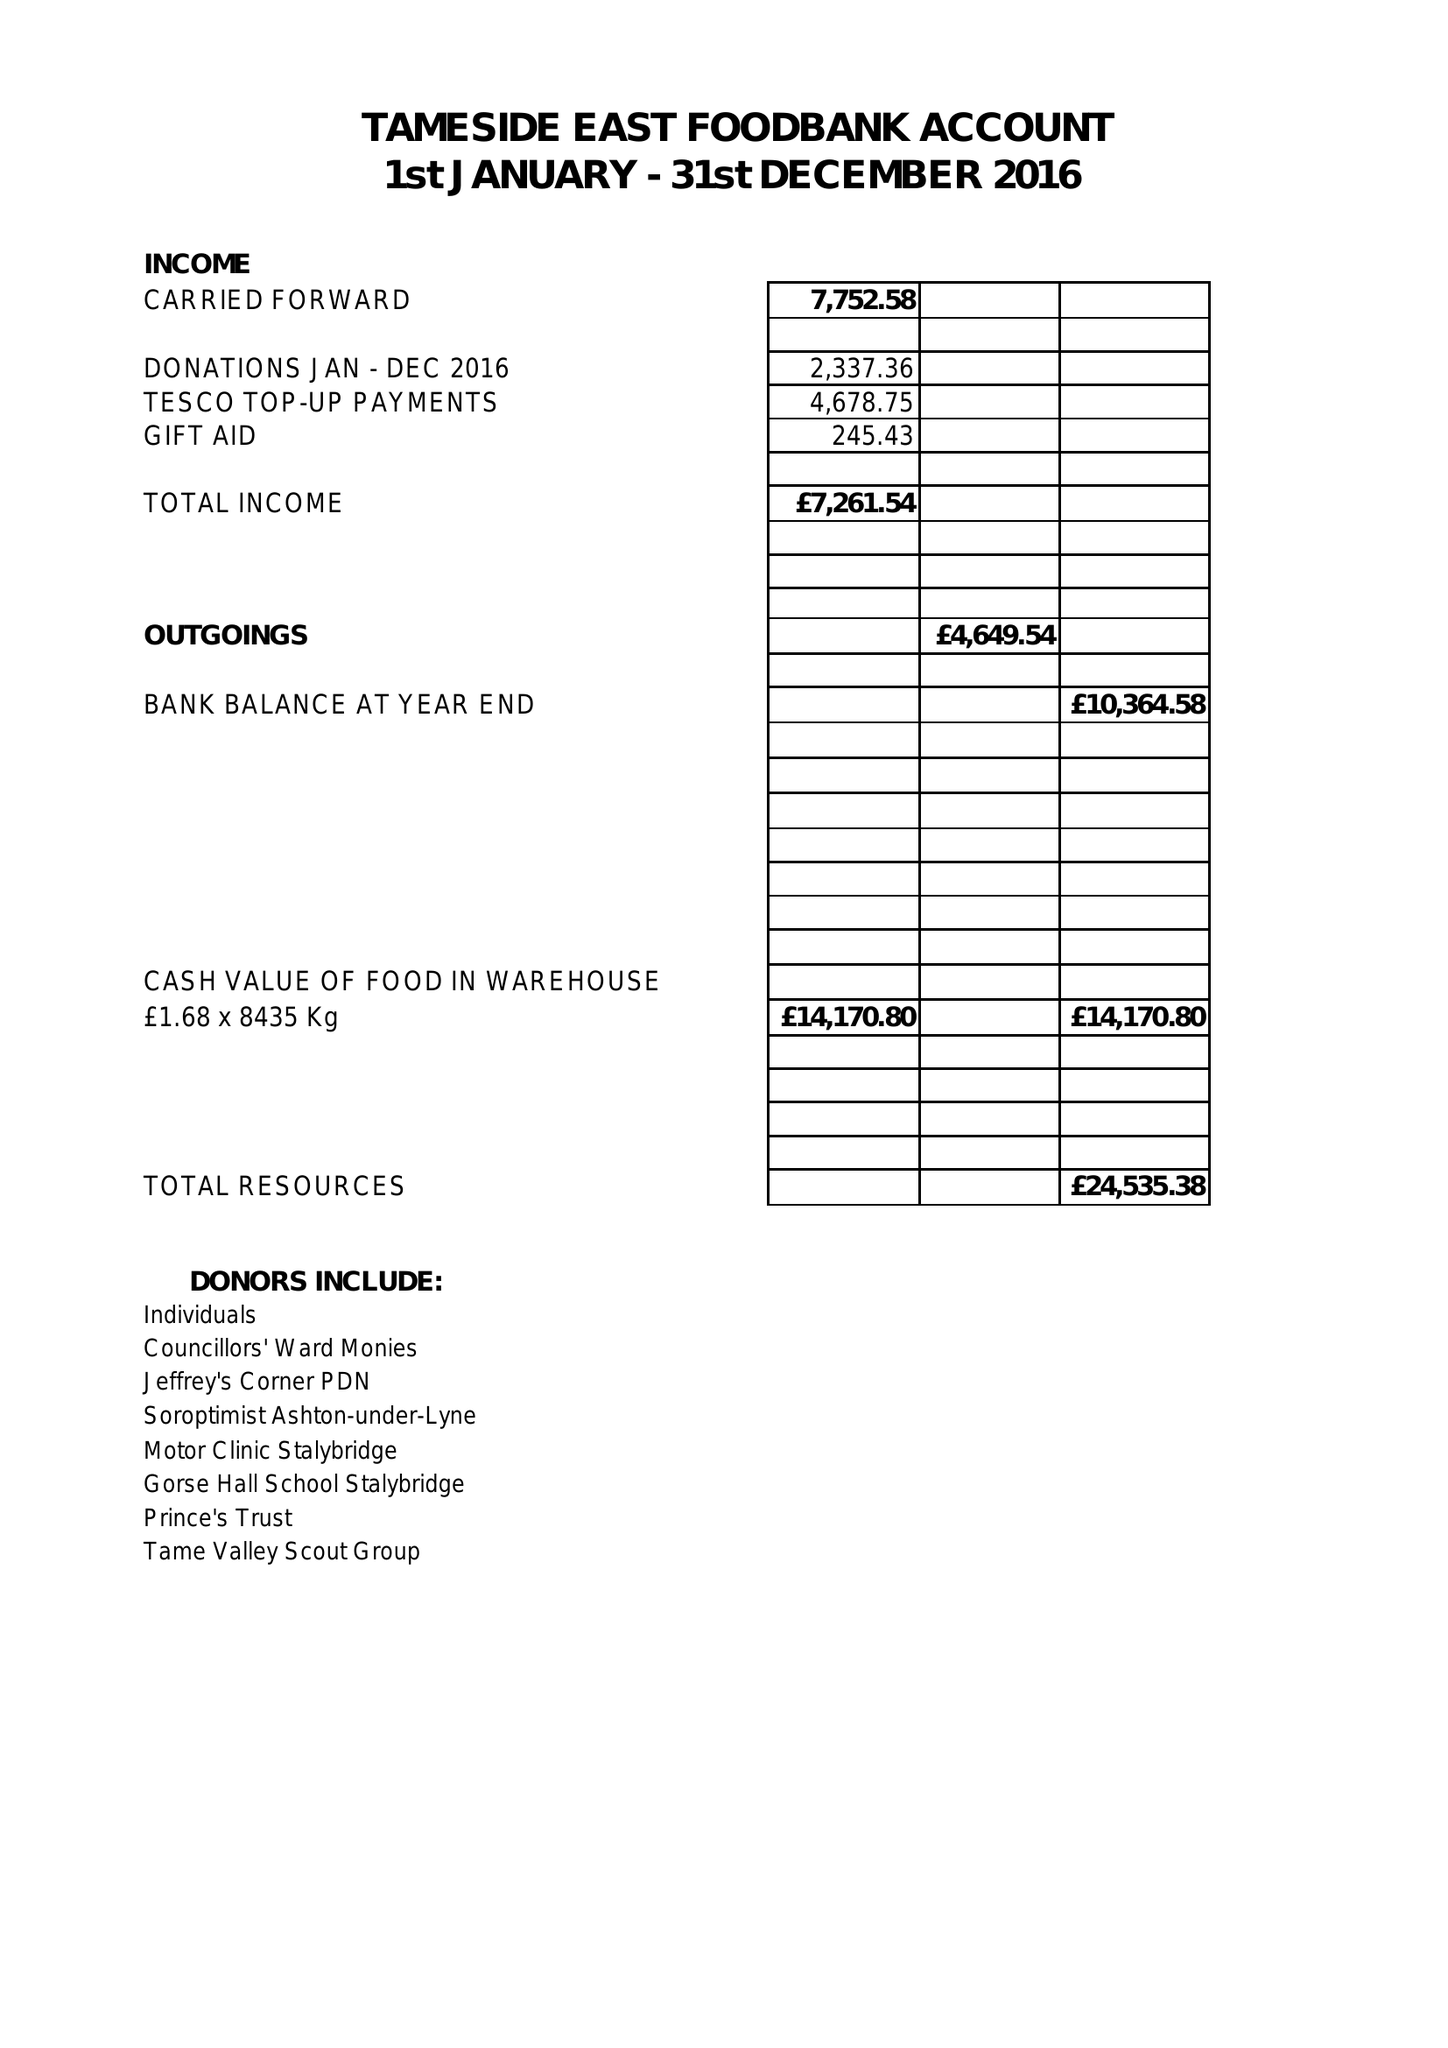What is the value for the charity_number?
Answer the question using a single word or phrase. 1161048 